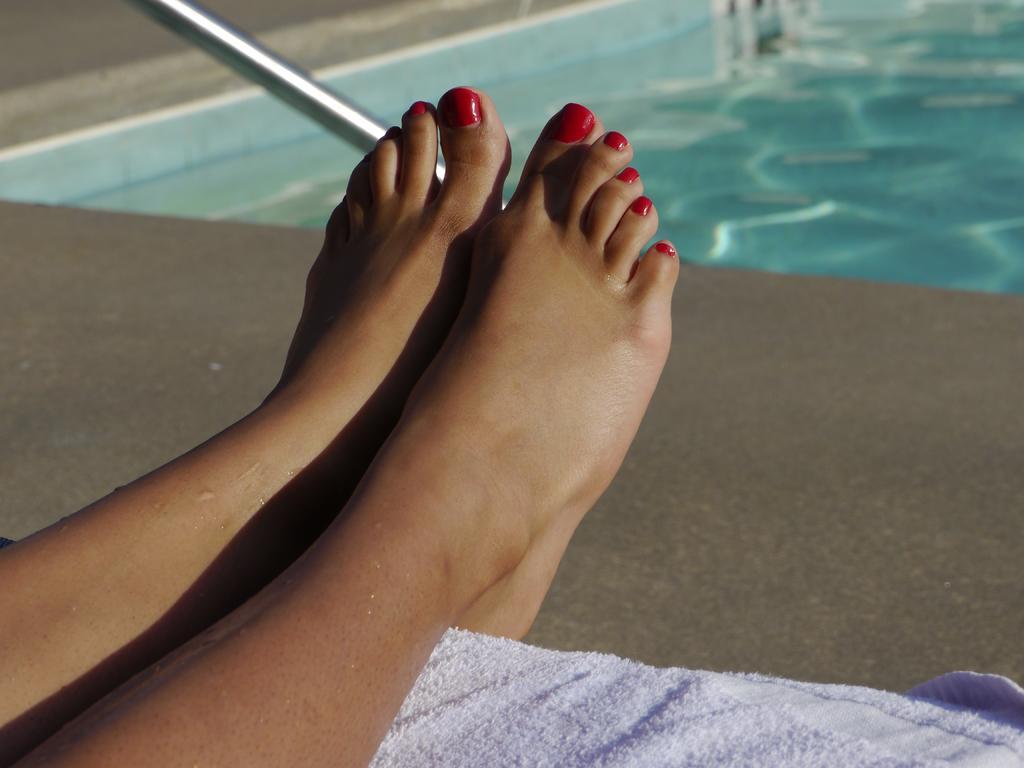Can you describe this image briefly? In this image a person's legs are visible. Legs are kept on the cloth. Behind there is a floor. Right side there is a poll having water. Left top there is a metal rod. 